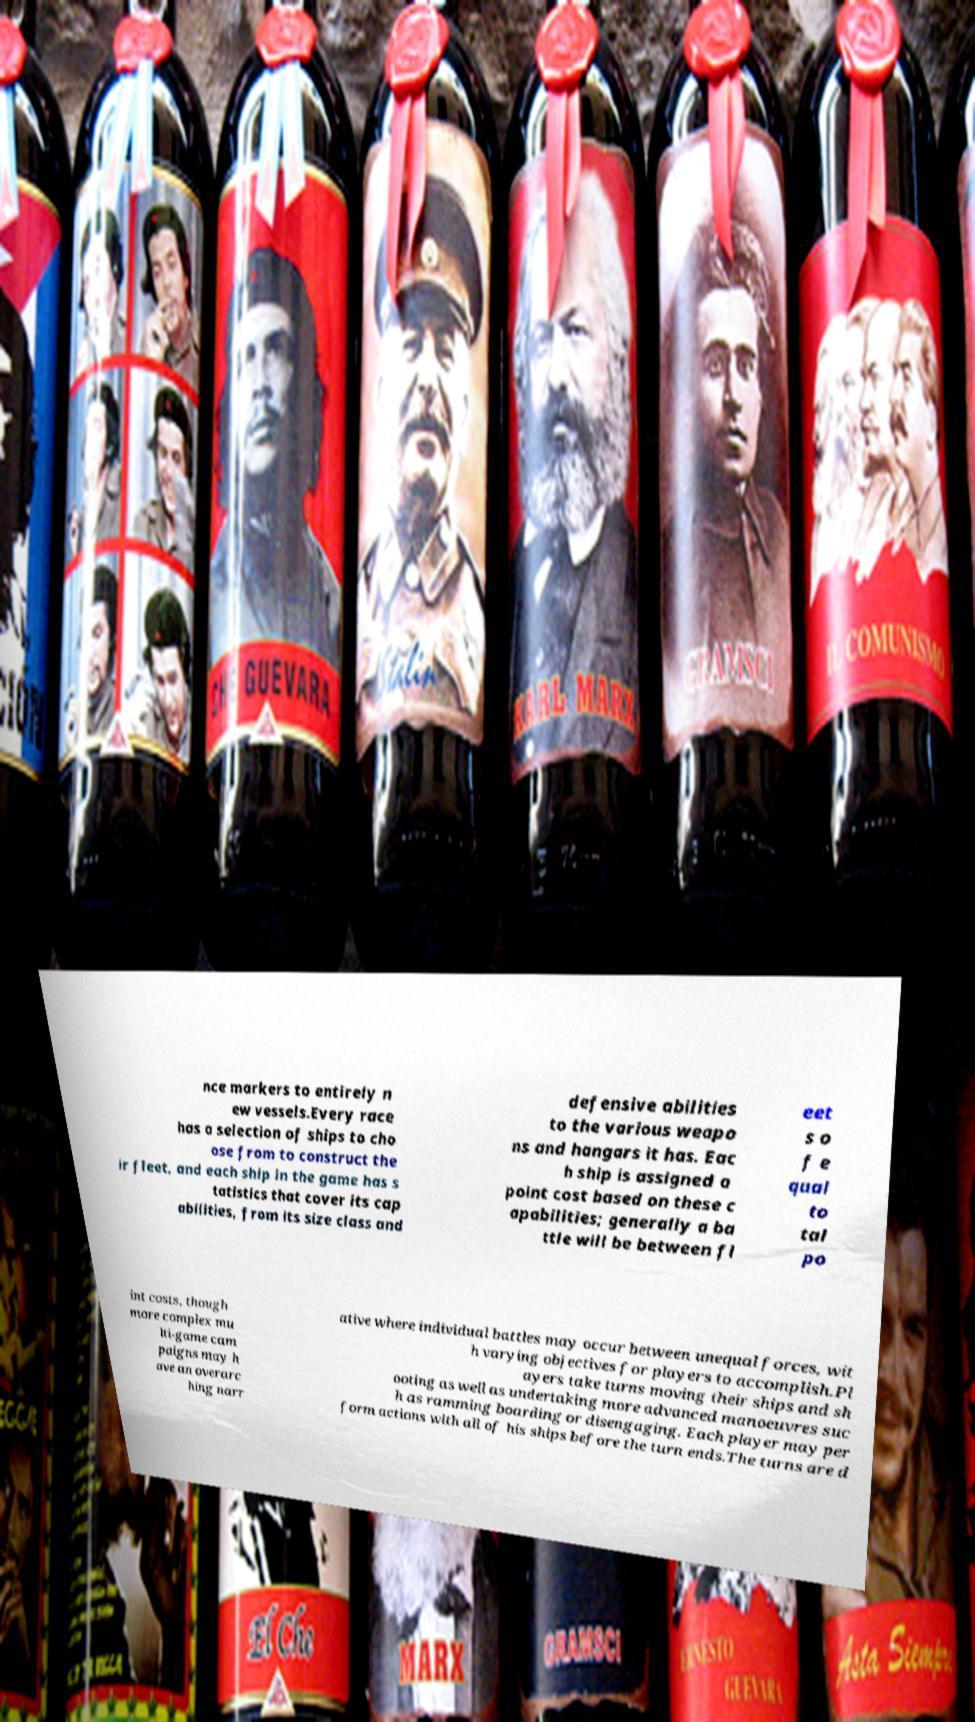For documentation purposes, I need the text within this image transcribed. Could you provide that? nce markers to entirely n ew vessels.Every race has a selection of ships to cho ose from to construct the ir fleet, and each ship in the game has s tatistics that cover its cap abilities, from its size class and defensive abilities to the various weapo ns and hangars it has. Eac h ship is assigned a point cost based on these c apabilities; generally a ba ttle will be between fl eet s o f e qual to tal po int costs, though more complex mu lti-game cam paigns may h ave an overarc hing narr ative where individual battles may occur between unequal forces, wit h varying objectives for players to accomplish.Pl ayers take turns moving their ships and sh ooting as well as undertaking more advanced manoeuvres suc h as ramming boarding or disengaging. Each player may per form actions with all of his ships before the turn ends.The turns are d 